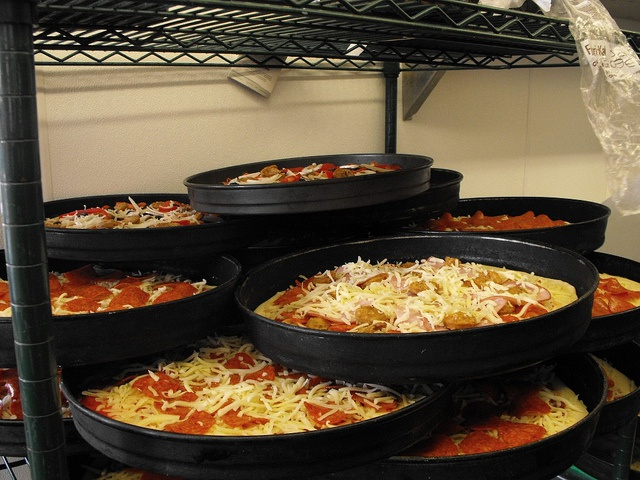Describe the objects in this image and their specific colors. I can see pizza in black, tan, and brown tones, bowl in black, maroon, and brown tones, pizza in black, khaki, tan, and olive tones, bowl in black, gray, and maroon tones, and bowl in black, gray, maroon, and brown tones in this image. 